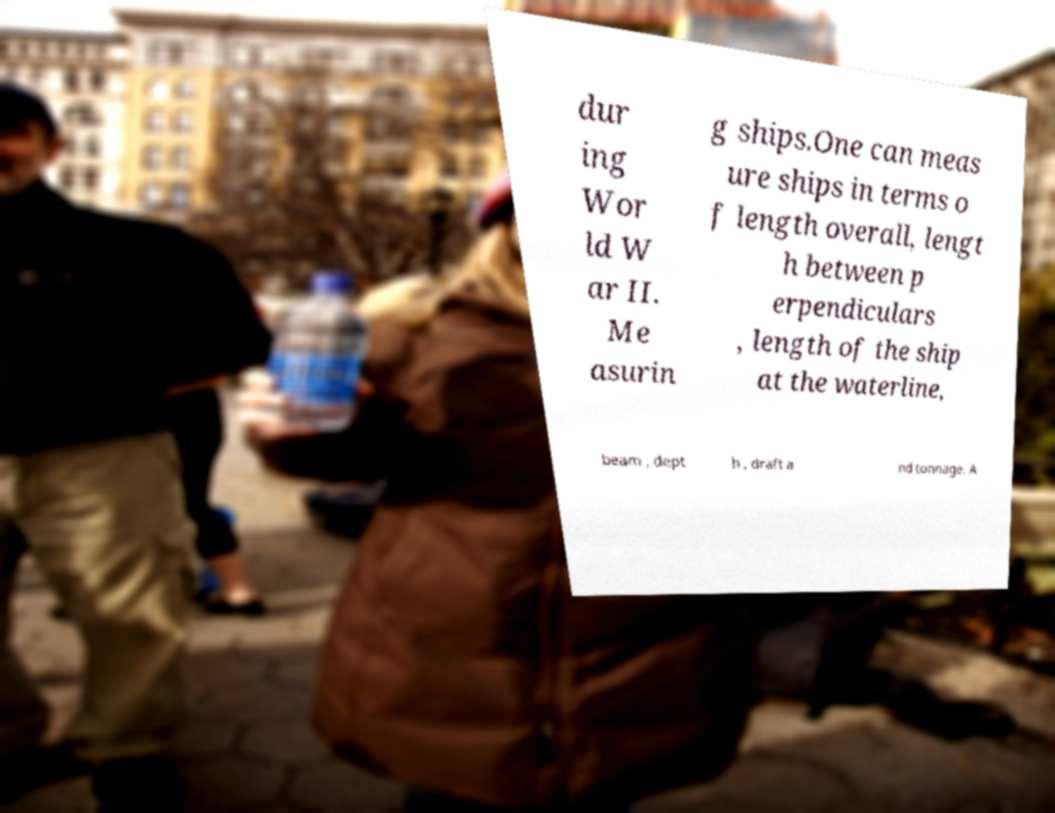For documentation purposes, I need the text within this image transcribed. Could you provide that? dur ing Wor ld W ar II. Me asurin g ships.One can meas ure ships in terms o f length overall, lengt h between p erpendiculars , length of the ship at the waterline, beam , dept h , draft a nd tonnage. A 